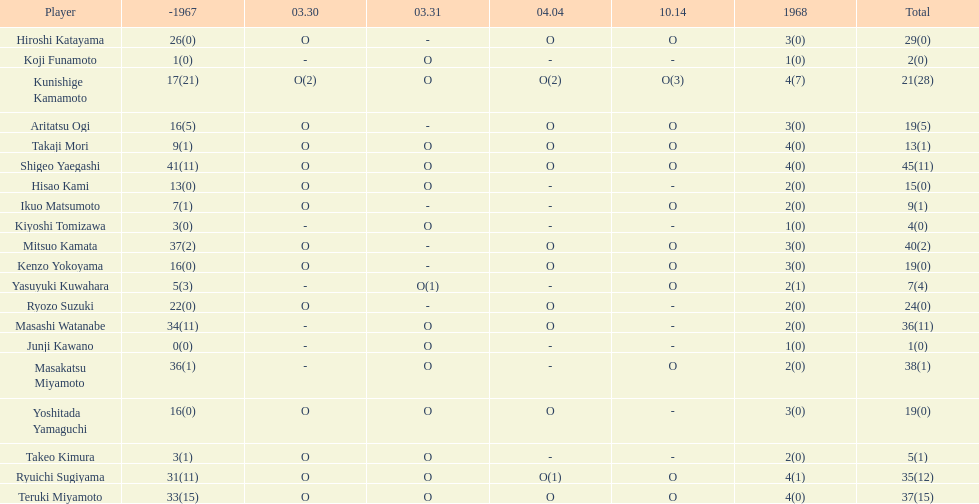How many more total appearances did shigeo yaegashi have than mitsuo kamata? 5. 